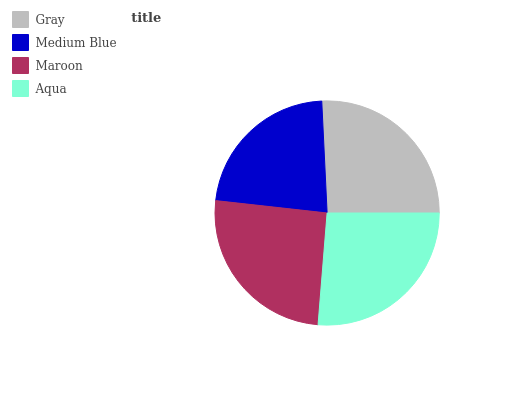Is Medium Blue the minimum?
Answer yes or no. Yes. Is Aqua the maximum?
Answer yes or no. Yes. Is Maroon the minimum?
Answer yes or no. No. Is Maroon the maximum?
Answer yes or no. No. Is Maroon greater than Medium Blue?
Answer yes or no. Yes. Is Medium Blue less than Maroon?
Answer yes or no. Yes. Is Medium Blue greater than Maroon?
Answer yes or no. No. Is Maroon less than Medium Blue?
Answer yes or no. No. Is Gray the high median?
Answer yes or no. Yes. Is Maroon the low median?
Answer yes or no. Yes. Is Aqua the high median?
Answer yes or no. No. Is Aqua the low median?
Answer yes or no. No. 